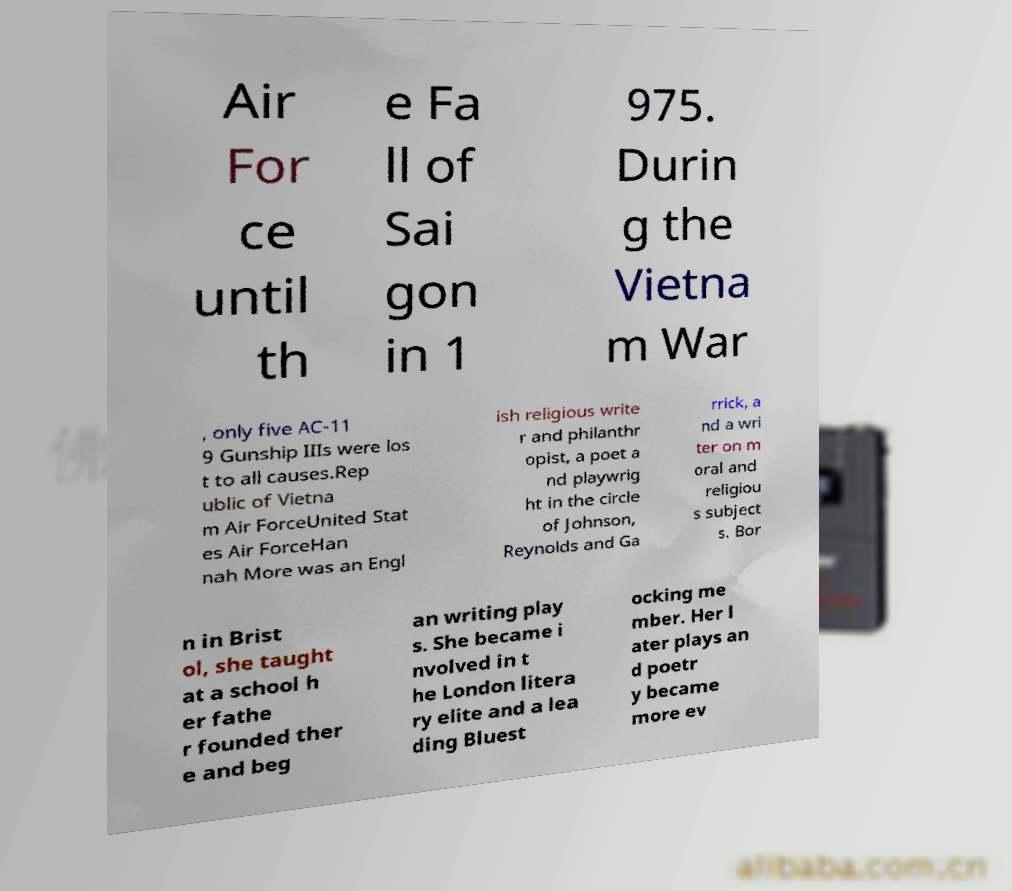What messages or text are displayed in this image? I need them in a readable, typed format. Air For ce until th e Fa ll of Sai gon in 1 975. Durin g the Vietna m War , only five AC-11 9 Gunship IIIs were los t to all causes.Rep ublic of Vietna m Air ForceUnited Stat es Air ForceHan nah More was an Engl ish religious write r and philanthr opist, a poet a nd playwrig ht in the circle of Johnson, Reynolds and Ga rrick, a nd a wri ter on m oral and religiou s subject s. Bor n in Brist ol, she taught at a school h er fathe r founded ther e and beg an writing play s. She became i nvolved in t he London litera ry elite and a lea ding Bluest ocking me mber. Her l ater plays an d poetr y became more ev 